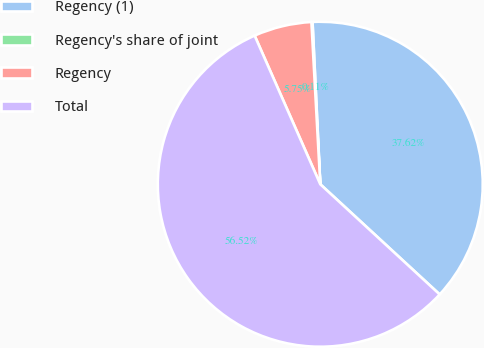Convert chart. <chart><loc_0><loc_0><loc_500><loc_500><pie_chart><fcel>Regency (1)<fcel>Regency's share of joint<fcel>Regency<fcel>Total<nl><fcel>37.62%<fcel>0.11%<fcel>5.75%<fcel>56.52%<nl></chart> 